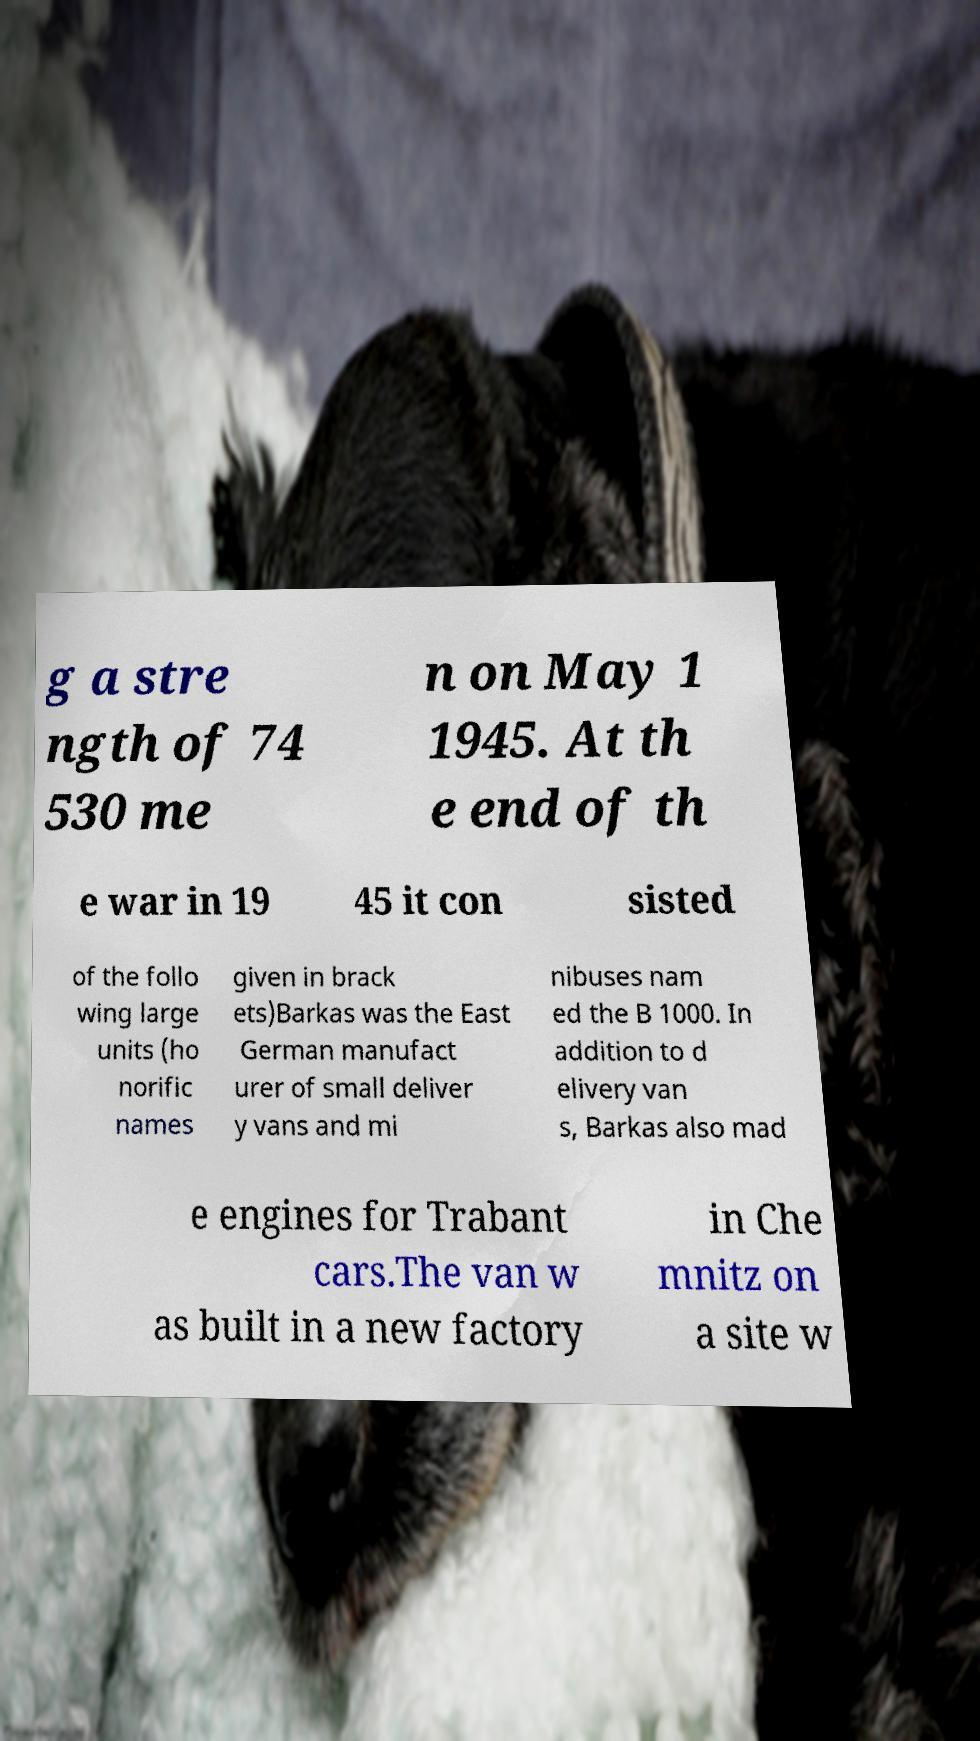For documentation purposes, I need the text within this image transcribed. Could you provide that? g a stre ngth of 74 530 me n on May 1 1945. At th e end of th e war in 19 45 it con sisted of the follo wing large units (ho norific names given in brack ets)Barkas was the East German manufact urer of small deliver y vans and mi nibuses nam ed the B 1000. In addition to d elivery van s, Barkas also mad e engines for Trabant cars.The van w as built in a new factory in Che mnitz on a site w 